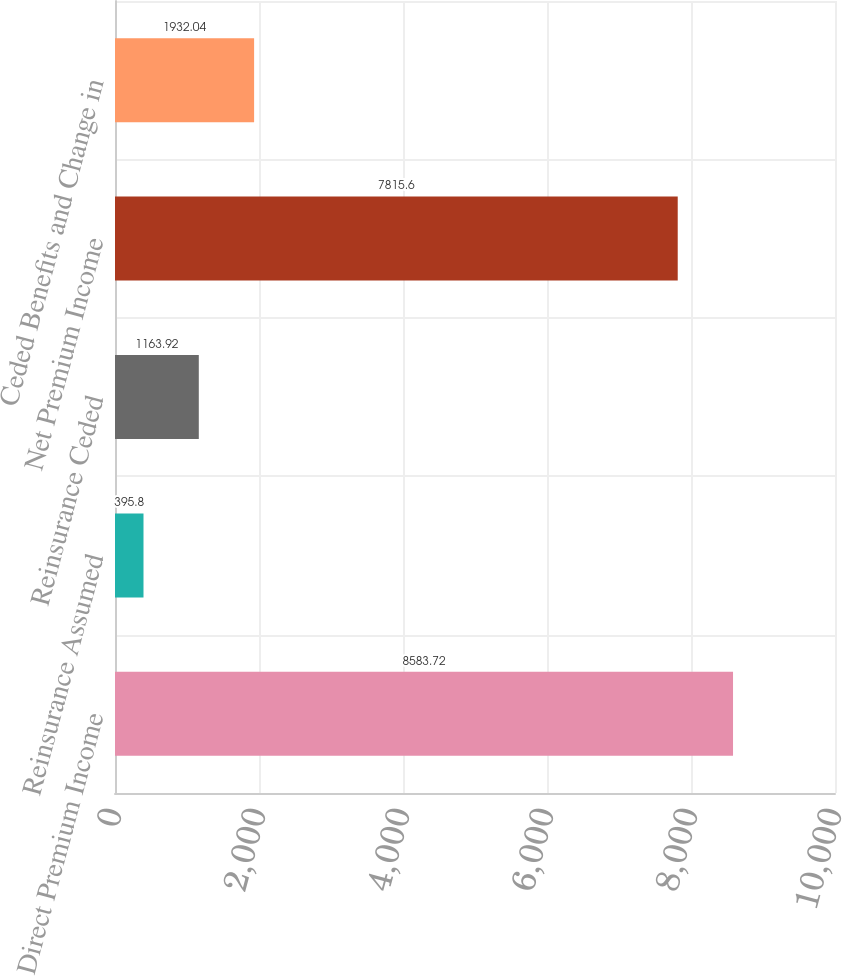Convert chart. <chart><loc_0><loc_0><loc_500><loc_500><bar_chart><fcel>Direct Premium Income<fcel>Reinsurance Assumed<fcel>Reinsurance Ceded<fcel>Net Premium Income<fcel>Ceded Benefits and Change in<nl><fcel>8583.72<fcel>395.8<fcel>1163.92<fcel>7815.6<fcel>1932.04<nl></chart> 